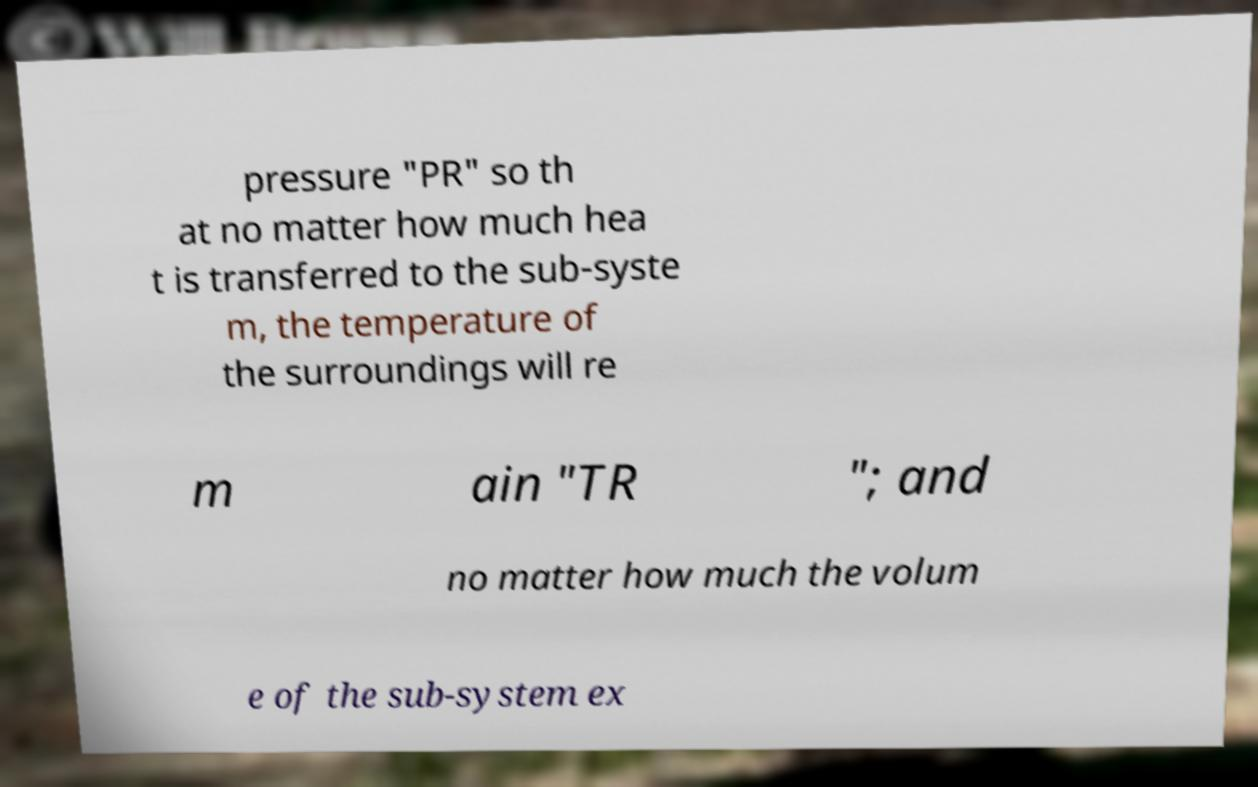What messages or text are displayed in this image? I need them in a readable, typed format. pressure "PR" so th at no matter how much hea t is transferred to the sub-syste m, the temperature of the surroundings will re m ain "TR "; and no matter how much the volum e of the sub-system ex 